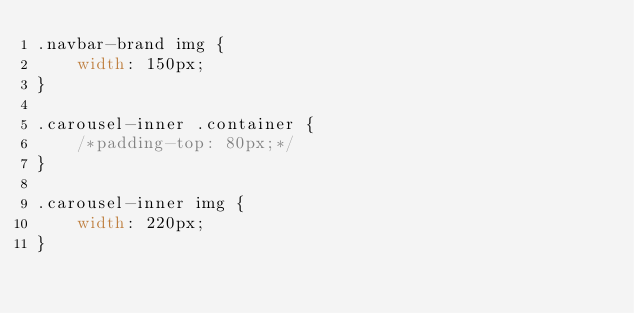Convert code to text. <code><loc_0><loc_0><loc_500><loc_500><_CSS_>.navbar-brand img {
	width: 150px;
}

.carousel-inner .container {
	/*padding-top: 80px;*/
}

.carousel-inner img {
	width: 220px;
}</code> 